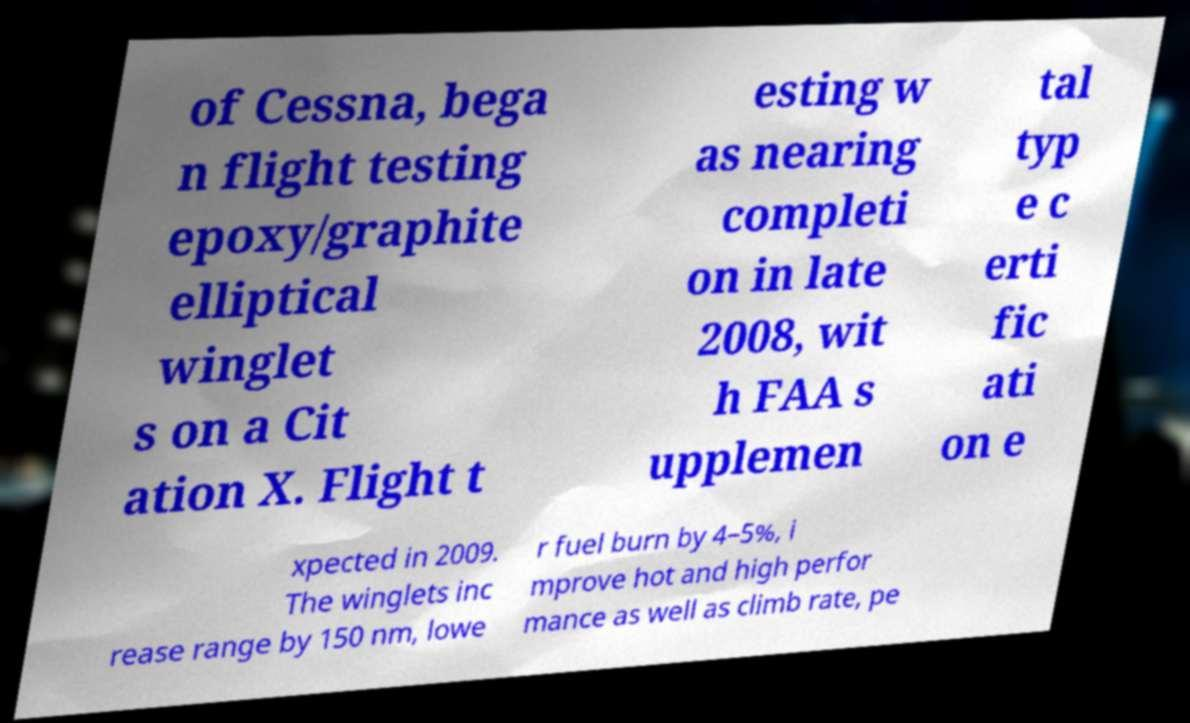Please identify and transcribe the text found in this image. of Cessna, bega n flight testing epoxy/graphite elliptical winglet s on a Cit ation X. Flight t esting w as nearing completi on in late 2008, wit h FAA s upplemen tal typ e c erti fic ati on e xpected in 2009. The winglets inc rease range by 150 nm, lowe r fuel burn by 4–5%, i mprove hot and high perfor mance as well as climb rate, pe 